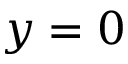Convert formula to latex. <formula><loc_0><loc_0><loc_500><loc_500>y = 0</formula> 